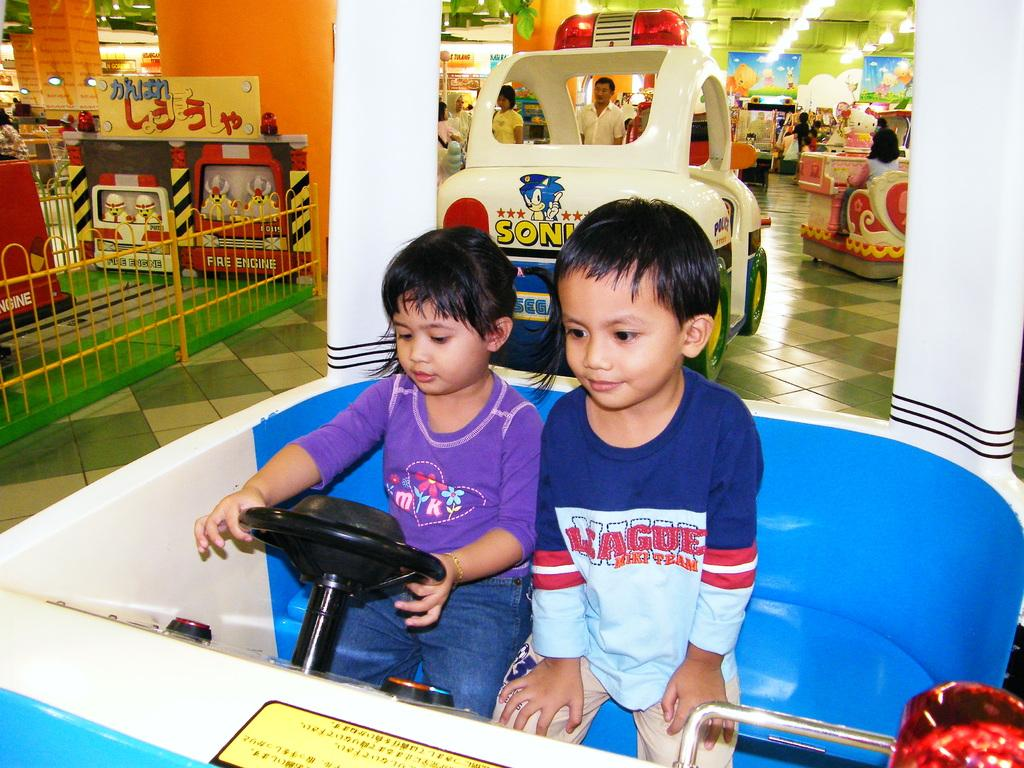What are the main subjects in the center of the image? There are children in the center of the image. What are the children doing in the image? The children are inside a toy car. What can be seen in the background of the image? There are people, posters, lights, and gaming equipment in the background of the image. What type of table can be seen in the image? There is no table present in the image. 